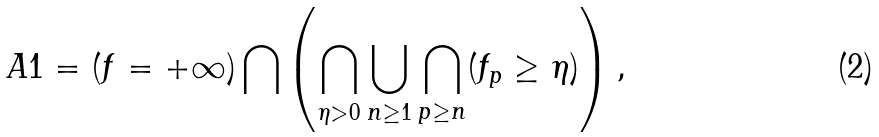Convert formula to latex. <formula><loc_0><loc_0><loc_500><loc_500>A 1 = ( f = + \infty ) \bigcap \left ( \bigcap _ { \eta > 0 } \bigcup _ { n \geq 1 } \bigcap _ { p \geq n } ( f _ { p } \geq \eta ) \right ) ,</formula> 